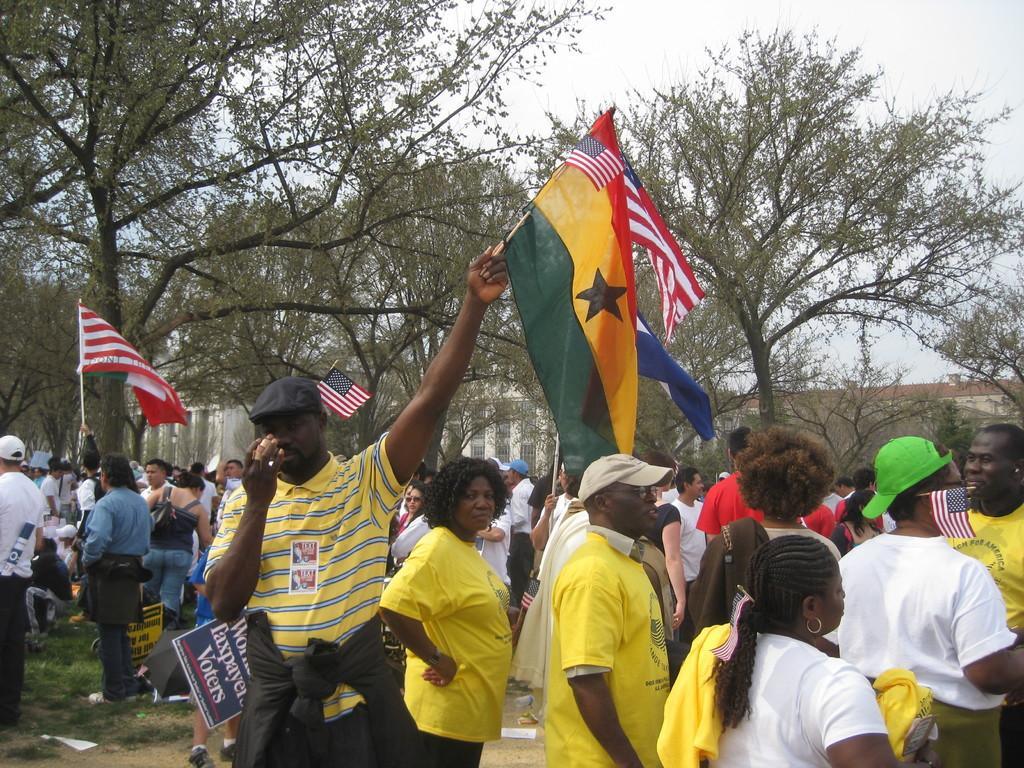How would you summarize this image in a sentence or two? This image is taken outdoors. At the top of the image there is a sky with clouds. In the background there are many trees and plants and there is a wooden fence. At the bottom of the image there is a ground with grass on it. In the middle of the image many people are standing on the ground and they are holding flags in their hands and a few are holding boards with text on them. 